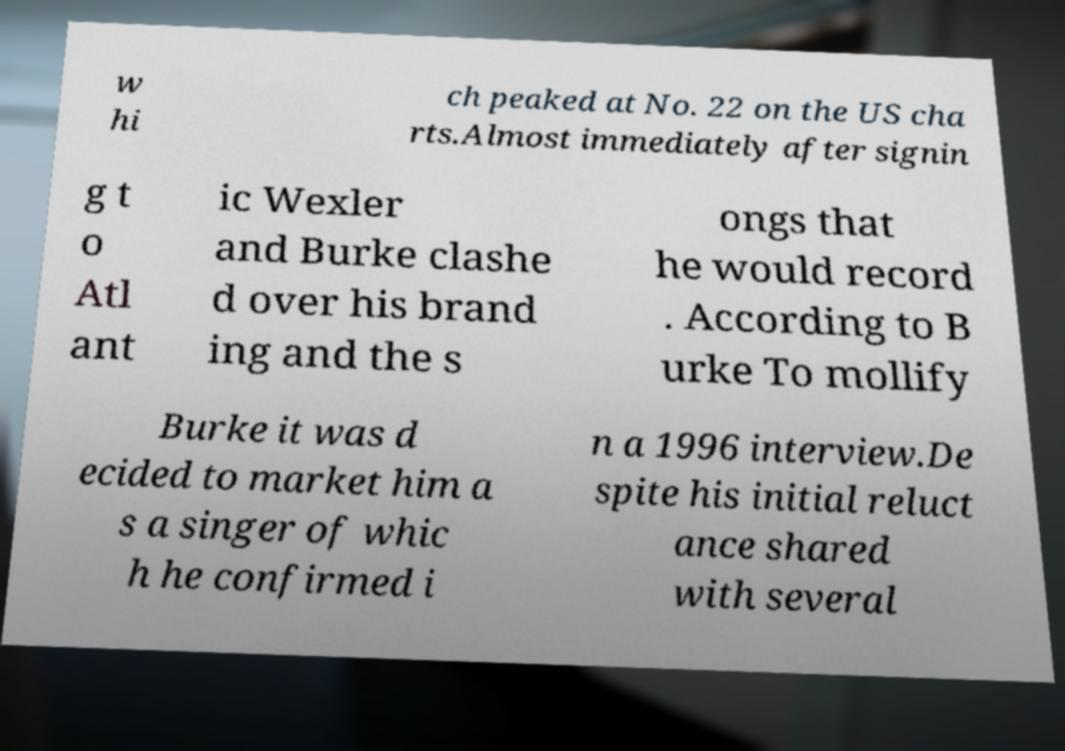There's text embedded in this image that I need extracted. Can you transcribe it verbatim? w hi ch peaked at No. 22 on the US cha rts.Almost immediately after signin g t o Atl ant ic Wexler and Burke clashe d over his brand ing and the s ongs that he would record . According to B urke To mollify Burke it was d ecided to market him a s a singer of whic h he confirmed i n a 1996 interview.De spite his initial reluct ance shared with several 